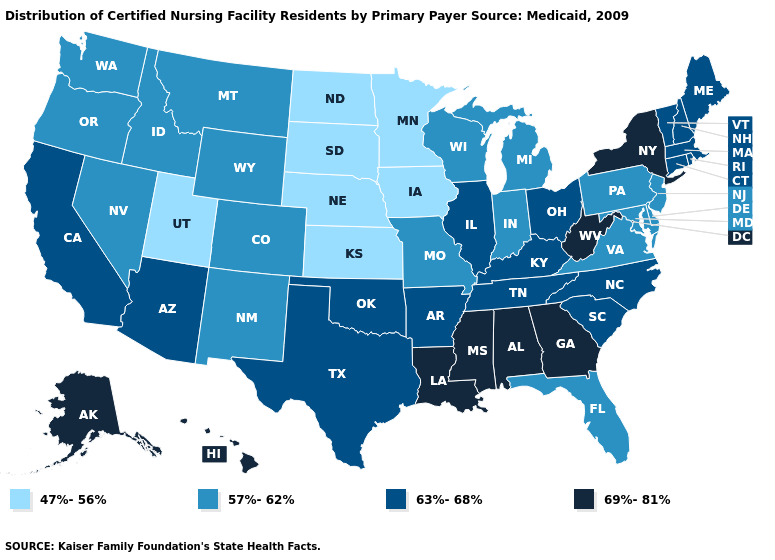Which states have the lowest value in the MidWest?
Answer briefly. Iowa, Kansas, Minnesota, Nebraska, North Dakota, South Dakota. Name the states that have a value in the range 47%-56%?
Give a very brief answer. Iowa, Kansas, Minnesota, Nebraska, North Dakota, South Dakota, Utah. Name the states that have a value in the range 69%-81%?
Concise answer only. Alabama, Alaska, Georgia, Hawaii, Louisiana, Mississippi, New York, West Virginia. Among the states that border Idaho , does Nevada have the highest value?
Answer briefly. Yes. Name the states that have a value in the range 57%-62%?
Write a very short answer. Colorado, Delaware, Florida, Idaho, Indiana, Maryland, Michigan, Missouri, Montana, Nevada, New Jersey, New Mexico, Oregon, Pennsylvania, Virginia, Washington, Wisconsin, Wyoming. Name the states that have a value in the range 47%-56%?
Answer briefly. Iowa, Kansas, Minnesota, Nebraska, North Dakota, South Dakota, Utah. Name the states that have a value in the range 69%-81%?
Quick response, please. Alabama, Alaska, Georgia, Hawaii, Louisiana, Mississippi, New York, West Virginia. Is the legend a continuous bar?
Answer briefly. No. What is the lowest value in states that border New Hampshire?
Answer briefly. 63%-68%. Which states have the highest value in the USA?
Concise answer only. Alabama, Alaska, Georgia, Hawaii, Louisiana, Mississippi, New York, West Virginia. What is the value of Montana?
Keep it brief. 57%-62%. Name the states that have a value in the range 63%-68%?
Answer briefly. Arizona, Arkansas, California, Connecticut, Illinois, Kentucky, Maine, Massachusetts, New Hampshire, North Carolina, Ohio, Oklahoma, Rhode Island, South Carolina, Tennessee, Texas, Vermont. What is the value of Idaho?
Keep it brief. 57%-62%. Name the states that have a value in the range 47%-56%?
Short answer required. Iowa, Kansas, Minnesota, Nebraska, North Dakota, South Dakota, Utah. Does the map have missing data?
Quick response, please. No. 